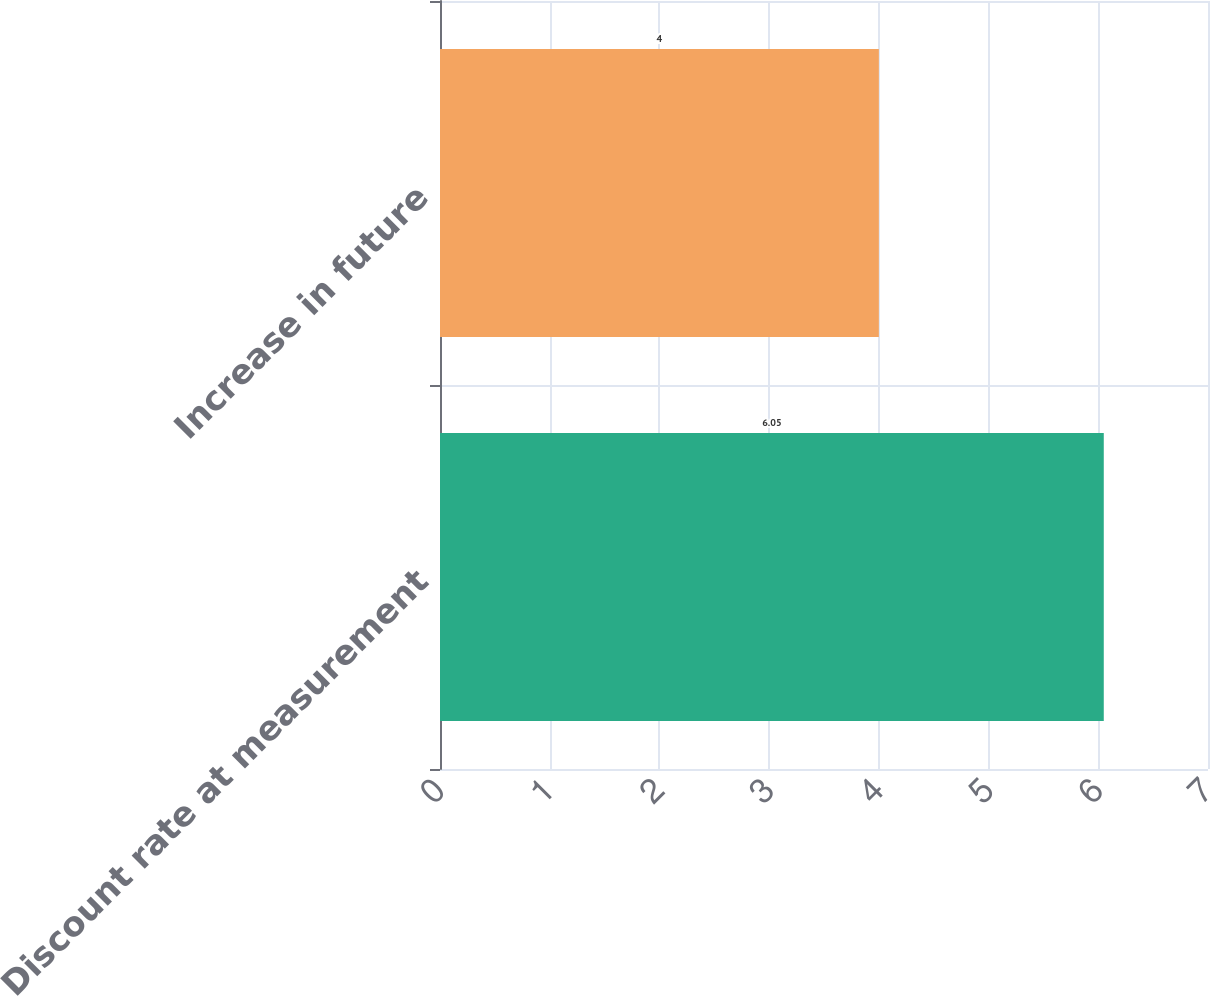Convert chart. <chart><loc_0><loc_0><loc_500><loc_500><bar_chart><fcel>Discount rate at measurement<fcel>Increase in future<nl><fcel>6.05<fcel>4<nl></chart> 